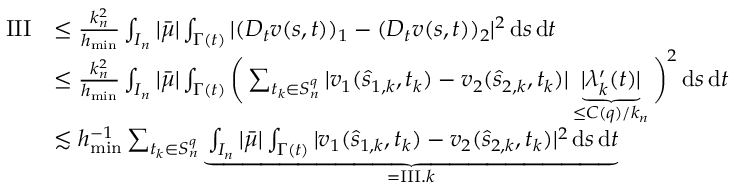Convert formula to latex. <formula><loc_0><loc_0><loc_500><loc_500>\begin{array} { r l } { I I I } & { \leq \frac { k _ { n } ^ { 2 } } { h _ { \min } } \int _ { I _ { n } } | \bar { \mu } | \int _ { \Gamma ( t ) } | ( D _ { t } v ( s , t ) ) _ { 1 } - ( D _ { t } v ( s , t ) ) _ { 2 } | ^ { 2 } \, d s \, d t } \\ & { \leq \frac { k _ { n } ^ { 2 } } { h _ { \min } } \int _ { I _ { n } } | \bar { \mu } | \int _ { \Gamma ( t ) } \left ( \sum _ { t _ { k } \in S _ { n } ^ { q } } | v _ { 1 } ( \hat { s } _ { 1 , k } , t _ { k } ) - v _ { 2 } ( \hat { s } _ { 2 , k } , t _ { k } ) | \underbrace { | \lambda _ { k } ^ { \prime } ( t ) | } _ { \leq C ( q ) / k _ { n } } \right ) ^ { 2 } \, d s \, d t } \\ & { \lesssim h _ { \min } ^ { - 1 } \sum _ { t _ { k } \in S _ { n } ^ { q } } \underbrace { \int _ { I _ { n } } | \bar { \mu } | \int _ { \Gamma ( t ) } | v _ { 1 } ( \hat { s } _ { 1 , k } , t _ { k } ) - v _ { 2 } ( \hat { s } _ { 2 , k } , t _ { k } ) | ^ { 2 } \, d s \, d t } _ { = I I I . k } } \end{array}</formula> 